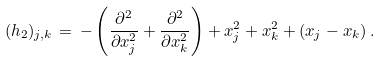<formula> <loc_0><loc_0><loc_500><loc_500>( h _ { 2 } ) _ { j , k } \, = \, - \left ( \frac { \partial ^ { 2 } } { \partial x _ { j } ^ { 2 } } + \frac { \partial ^ { 2 } } { \partial x _ { k } ^ { 2 } } \right ) + x _ { j } ^ { 2 } + x _ { k } ^ { 2 } + ( x _ { j } - x _ { k } ) \, .</formula> 